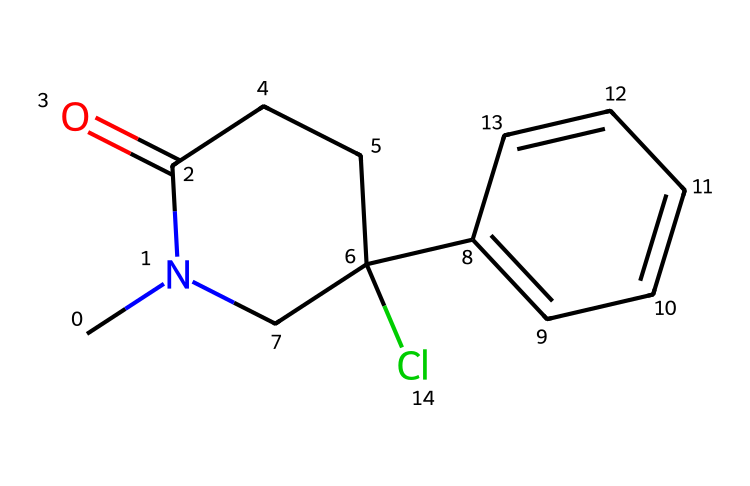What is the total number of carbon atoms in ketamine? By analyzing the SMILES representation, we can count the carbon atoms (C). In the structure, there are seven carbon atoms indicated by the letter 'C' in various sections of the chemical formula.
Answer: seven How many nitrogen atoms are present in the ketamine structure? The SMILES representation contains the letter 'N', which represents nitrogen. In this case, there is one nitrogen atom present in the structure of ketamine.
Answer: one What is the primary functional group in ketamine? The chemical features a carbonyl group (C=O) as indicated by the portion "C(=O)" in the SMILES. This carbonyl group identifies it as an amide, which is a characteristic functional group in ketamine.
Answer: amide What is the molecular weight of ketamine? To find the molecular weight, count the individual atoms and their respective weights: C (12.01 g/mol), H (1.008 g/mol), N (14.01 g/mol), and Cl (35.45 g/mol). After calculating based on the counts from the structure, the molecular weight totals to approximately 237.73 g/mol.
Answer: 237.73 g/mol What indicates that ketamine is a chlorinated compound? The presence of a chlorine atom in the SMILES is indicated by 'Cl'. This shows that ketamine has a chlorine substituent in its structure, confirming its classification as a chlorinated compound.
Answer: chlorine How does the cyclic structure in ketamine contribute to its properties? The cyclization indicated by 'N1' and the surrounding carbon atoms suggests it is a piperidine derivative. This cyclic structure affects the pharmacological properties, including its ability to disrupt normal neurotransmitter signaling, contributing to its anesthetic effects.
Answer: piperidine derivative 